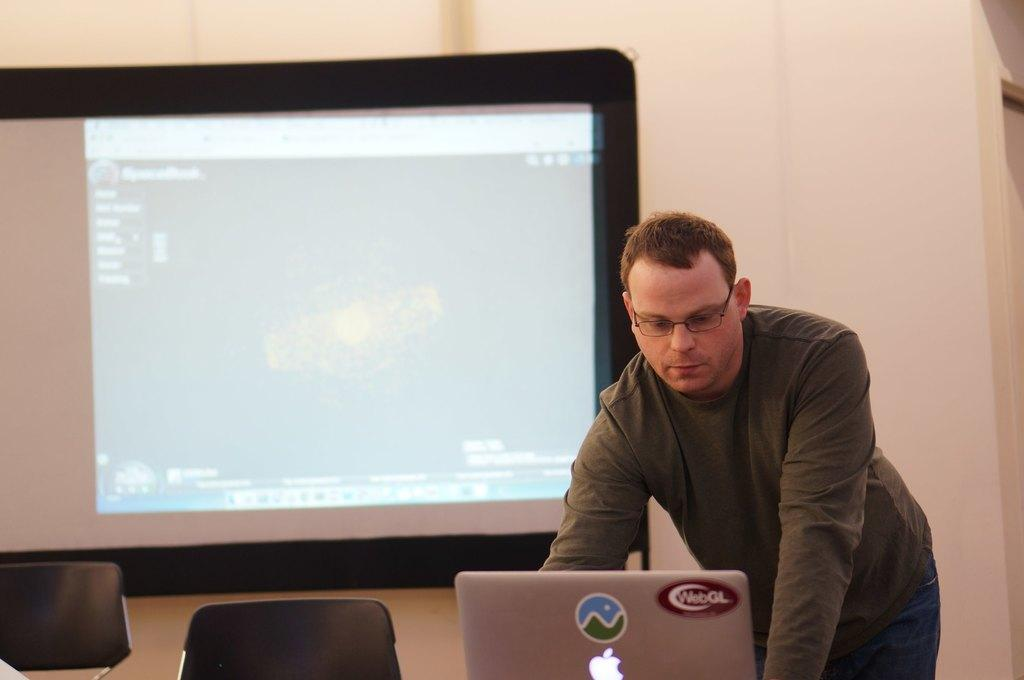What is the main subject of the image? There is a person standing in the image. Can you describe the person's appearance? The person is wearing spectacles. What object is in front of the person? There is a laptop in front of the person. Are there any other objects or furniture visible in the image? Yes, there are two chairs in the left bottom of the image, and there is a screen attached to the wall behind the person. What type of humor can be seen in the person's knee in the image? There is no humor or knee visible in the image; it only shows a person standing with a laptop in front of them, two chairs, and a screen on the wall. 